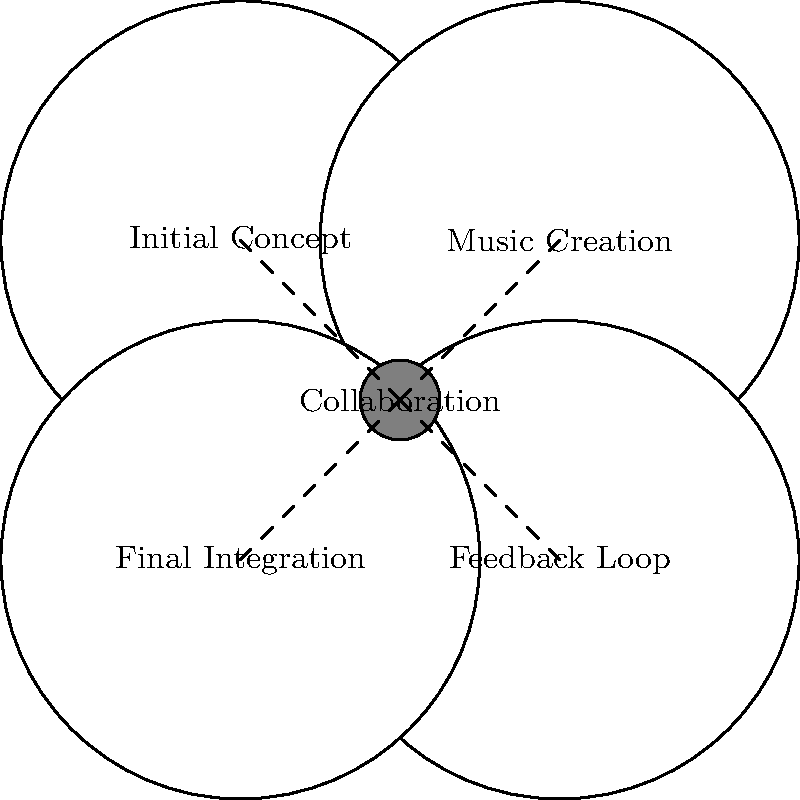In the collaborative process between a musician and film director, which stage typically involves the most intense back-and-forth communication and refinement of ideas? To answer this question, let's examine the stages in the collaborative process between a musician and film director:

1. Initial Concept: This is where the director shares their vision and the musician begins to brainstorm ideas.

2. Music Creation: The musician creates initial drafts or demos based on the concept.

3. Feedback Loop: This stage involves intense communication between the musician and director. The director provides feedback on the music, and the musician makes adjustments. This process may repeat several times until both parties are satisfied.

4. Final Integration: The approved music is integrated into the film.

The Feedback Loop stage (3) typically involves the most intense back-and-forth communication and refinement of ideas. This is because:

a) It's an iterative process where the musician and director exchange ideas multiple times.
b) The music is continuously refined based on the director's feedback.
c) It requires the most collaboration to ensure the music aligns perfectly with the director's vision.
d) This stage often involves detailed discussions about specific scenes, emotions, and timing.

As a boundary-pushing artist, you would likely find this stage both challenging and creatively stimulating, as it allows you to fine-tune your work to perfectly complement the director's vision while maintaining your artistic integrity.
Answer: Feedback Loop 